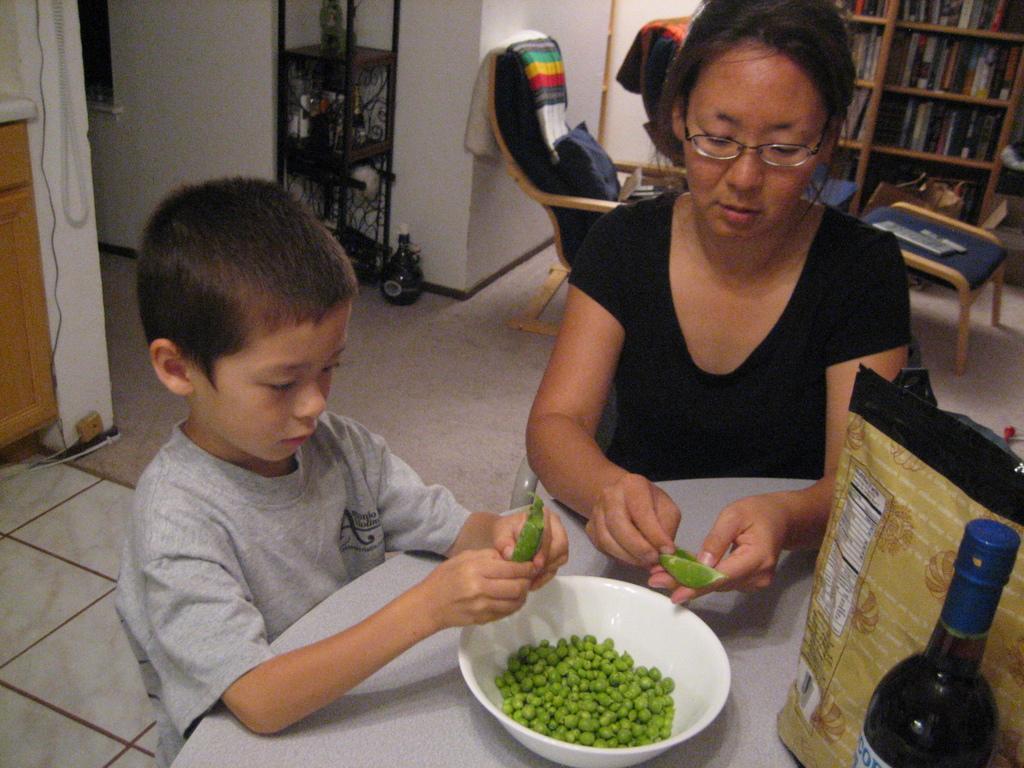How would you summarize this image in a sentence or two? In the background we can see the wall, books arranged in the racks, chair, a table and object on the table. On the floor we can see a bottle. Beside to a bottle we can see a black stand. At the bottom we can see the floor and a floor carpet. On the right side we can see a woman and a boy holding peas in their hands. On the table we can see a bag, bottle and peas in a white bowl. On the left side we can see the wall, wooden cupboard and wires. 